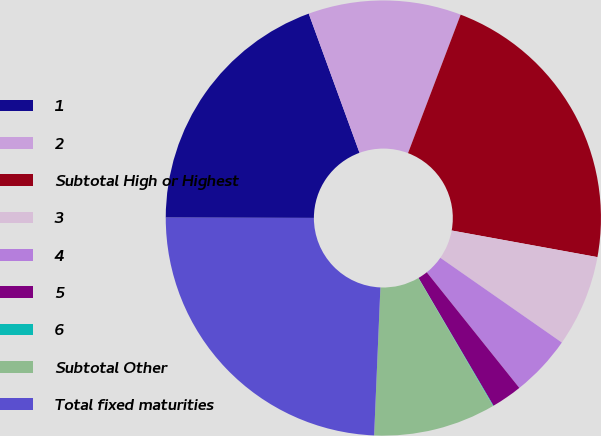Convert chart to OTSL. <chart><loc_0><loc_0><loc_500><loc_500><pie_chart><fcel>1<fcel>2<fcel>Subtotal High or Highest<fcel>3<fcel>4<fcel>5<fcel>6<fcel>Subtotal Other<fcel>Total fixed maturities<nl><fcel>19.4%<fcel>11.35%<fcel>22.09%<fcel>6.82%<fcel>4.56%<fcel>2.3%<fcel>0.04%<fcel>9.08%<fcel>24.35%<nl></chart> 